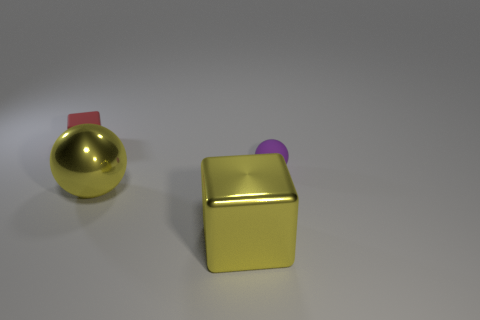Add 2 big purple objects. How many objects exist? 6 Add 3 red rubber cubes. How many red rubber cubes are left? 4 Add 3 blue matte cylinders. How many blue matte cylinders exist? 3 Subtract 0 purple cubes. How many objects are left? 4 Subtract all red things. Subtract all big yellow metallic objects. How many objects are left? 1 